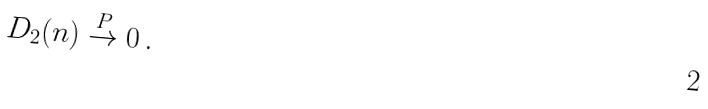Convert formula to latex. <formula><loc_0><loc_0><loc_500><loc_500>D _ { 2 } ( n ) \stackrel { P } { \to } 0 \, .</formula> 